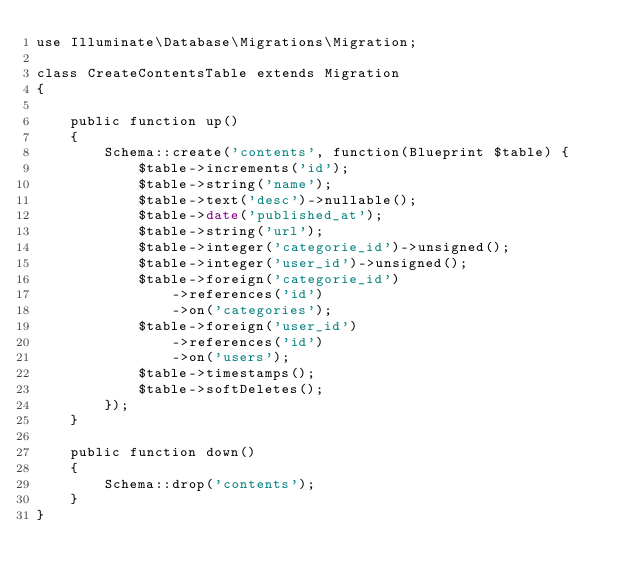<code> <loc_0><loc_0><loc_500><loc_500><_PHP_>use Illuminate\Database\Migrations\Migration;

class CreateContentsTable extends Migration
{

    public function up()
    {
        Schema::create('contents', function(Blueprint $table) {
            $table->increments('id');
            $table->string('name');
            $table->text('desc')->nullable();
            $table->date('published_at');
            $table->string('url');
            $table->integer('categorie_id')->unsigned();
            $table->integer('user_id')->unsigned();
            $table->foreign('categorie_id')
                ->references('id')
                ->on('categories');
            $table->foreign('user_id')
                ->references('id')
                ->on('users');
            $table->timestamps();
            $table->softDeletes();
        });
    }

    public function down()
    {
        Schema::drop('contents');
    }
}
</code> 